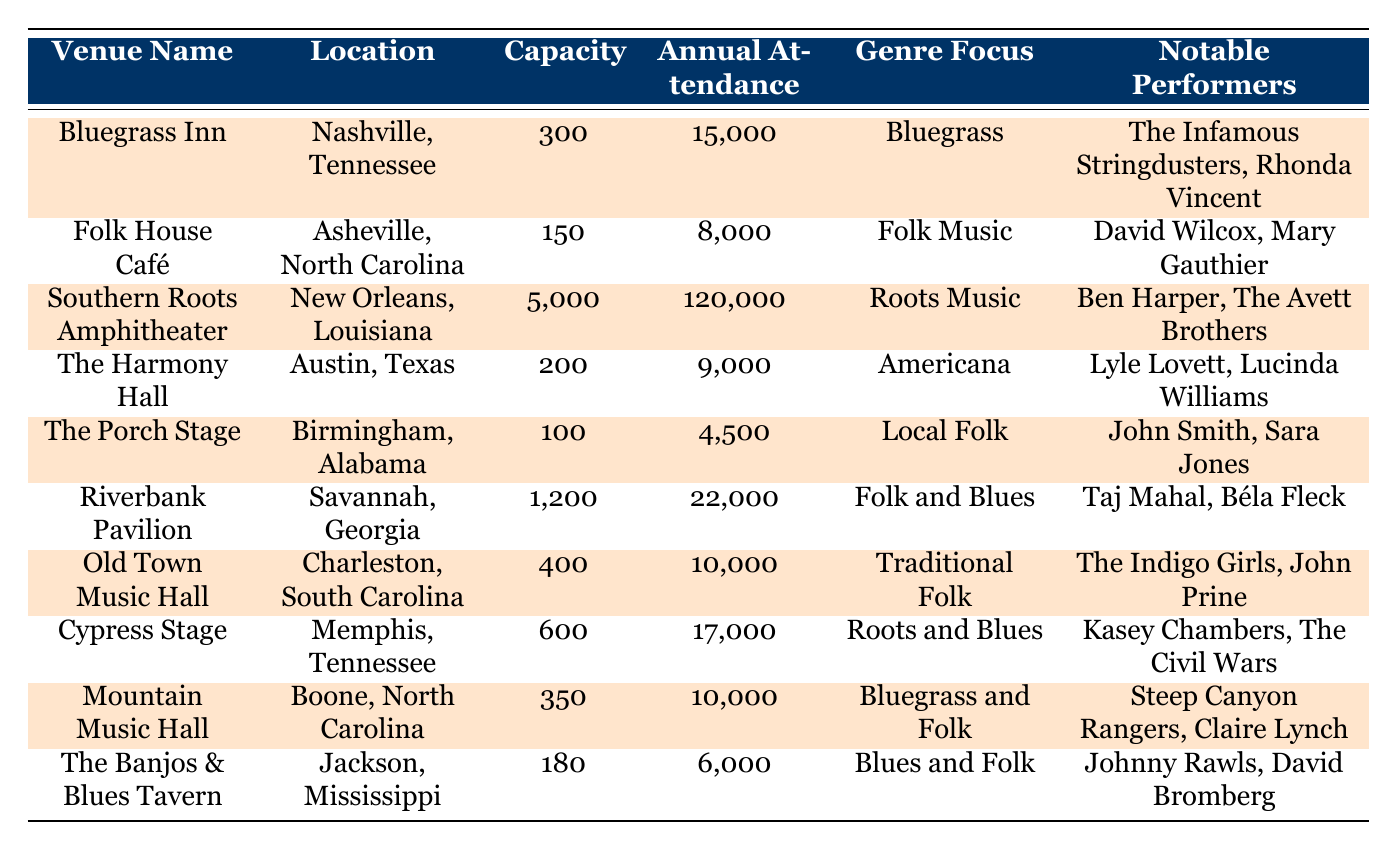What is the venue with the highest annual attendance? The table shows the annual attendance of each venue, and when comparing the listed values, "Southern Roots Amphitheater" in New Orleans, Louisiana, has the highest attendance at 120,000.
Answer: Southern Roots Amphitheater Which venue focuses on Americana music? The table indicates the genre focus for each venue, and "The Harmony Hall" in Austin, Texas, has a genre focus on Americana music.
Answer: The Harmony Hall What is the total capacity of all listed venues? The total capacity is calculated by summing the capacities of each venue: 300 + 150 + 5000 + 200 + 100 + 1200 + 400 + 600 + 350 + 180 = 7,680.
Answer: 7680 Is the annual attendance of "Folk House Café" greater than 10,000? The annual attendance for "Folk House Café" is listed as 8,000, which is less than 10,000. Therefore, the statement is false.
Answer: No Which cities have music venues with a capacity greater than 500? By checking the capacity column, the venues "Southern Roots Amphitheater" (5,000), "Riverbank Pavilion" (1,200), and "Cypress Stage" (600) have capacities greater than 500, and they are in New Orleans, Savannah, and Memphis respectively.
Answer: New Orleans, Savannah, Memphis What is the average annual attendance for venues focusing on Folk Music? The venues that focus on Folk Music are "Folk House Café," which has an attendance of 8,000, and "Riverbank Pavilion," which has 22,000. Thus, the average is (8,000 + 22,000) / 2 = 15,000.
Answer: 15000 Do any venues list "John Prine" as a notable performer? The table shows that "Old Town Music Hall" in Charleston, South Carolina, lists "John Prine" as a notable performer, which confirms that the statement is true.
Answer: Yes Which venue has the smallest annual attendance and what is that number? By comparing the annual attendance values, "The Porch Stage" in Birmingham, Alabama, has the smallest attendance at 4,500.
Answer: The Porch Stage, 4500 